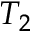Convert formula to latex. <formula><loc_0><loc_0><loc_500><loc_500>T _ { 2 }</formula> 